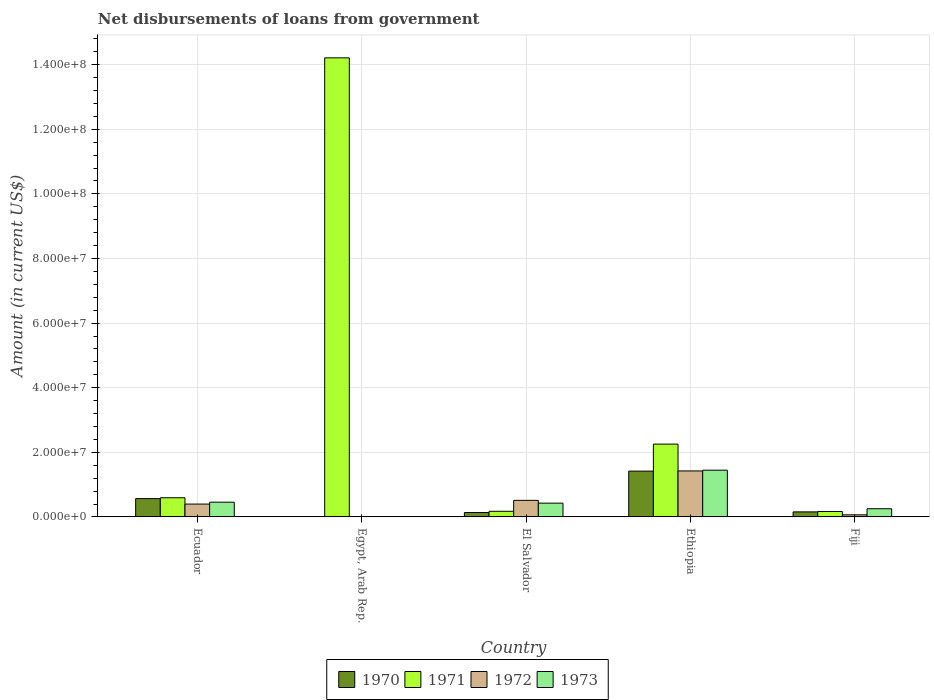How many different coloured bars are there?
Provide a short and direct response. 4. Are the number of bars per tick equal to the number of legend labels?
Offer a terse response. No. Are the number of bars on each tick of the X-axis equal?
Provide a succinct answer. No. What is the label of the 1st group of bars from the left?
Your answer should be compact. Ecuador. In how many cases, is the number of bars for a given country not equal to the number of legend labels?
Your response must be concise. 1. What is the amount of loan disbursed from government in 1972 in El Salvador?
Provide a short and direct response. 5.13e+06. Across all countries, what is the maximum amount of loan disbursed from government in 1973?
Keep it short and to the point. 1.45e+07. Across all countries, what is the minimum amount of loan disbursed from government in 1971?
Ensure brevity in your answer.  1.69e+06. In which country was the amount of loan disbursed from government in 1973 maximum?
Give a very brief answer. Ethiopia. What is the total amount of loan disbursed from government in 1970 in the graph?
Make the answer very short. 2.28e+07. What is the difference between the amount of loan disbursed from government in 1970 in Ecuador and that in El Salvador?
Ensure brevity in your answer.  4.32e+06. What is the difference between the amount of loan disbursed from government in 1973 in Ethiopia and the amount of loan disbursed from government in 1971 in Fiji?
Your answer should be compact. 1.28e+07. What is the average amount of loan disbursed from government in 1973 per country?
Your answer should be very brief. 5.17e+06. What is the difference between the amount of loan disbursed from government of/in 1972 and amount of loan disbursed from government of/in 1971 in El Salvador?
Provide a short and direct response. 3.39e+06. In how many countries, is the amount of loan disbursed from government in 1971 greater than 116000000 US$?
Give a very brief answer. 1. What is the ratio of the amount of loan disbursed from government in 1971 in Ecuador to that in Egypt, Arab Rep.?
Make the answer very short. 0.04. Is the amount of loan disbursed from government in 1973 in Ecuador less than that in Fiji?
Offer a terse response. No. What is the difference between the highest and the second highest amount of loan disbursed from government in 1973?
Give a very brief answer. 9.90e+06. What is the difference between the highest and the lowest amount of loan disbursed from government in 1971?
Make the answer very short. 1.40e+08. Is the sum of the amount of loan disbursed from government in 1971 in Ethiopia and Fiji greater than the maximum amount of loan disbursed from government in 1973 across all countries?
Your response must be concise. Yes. Is it the case that in every country, the sum of the amount of loan disbursed from government in 1973 and amount of loan disbursed from government in 1971 is greater than the sum of amount of loan disbursed from government in 1970 and amount of loan disbursed from government in 1972?
Provide a short and direct response. No. Is it the case that in every country, the sum of the amount of loan disbursed from government in 1970 and amount of loan disbursed from government in 1972 is greater than the amount of loan disbursed from government in 1971?
Provide a succinct answer. No. How many countries are there in the graph?
Offer a very short reply. 5. What is the difference between two consecutive major ticks on the Y-axis?
Your answer should be very brief. 2.00e+07. Are the values on the major ticks of Y-axis written in scientific E-notation?
Offer a very short reply. Yes. Does the graph contain any zero values?
Offer a terse response. Yes. Does the graph contain grids?
Offer a very short reply. Yes. Where does the legend appear in the graph?
Your answer should be very brief. Bottom center. What is the title of the graph?
Offer a very short reply. Net disbursements of loans from government. Does "1967" appear as one of the legend labels in the graph?
Your answer should be compact. No. What is the label or title of the X-axis?
Make the answer very short. Country. What is the Amount (in current US$) in 1970 in Ecuador?
Keep it short and to the point. 5.67e+06. What is the Amount (in current US$) in 1971 in Ecuador?
Offer a very short reply. 5.93e+06. What is the Amount (in current US$) in 1972 in Ecuador?
Give a very brief answer. 3.98e+06. What is the Amount (in current US$) of 1973 in Ecuador?
Provide a short and direct response. 4.56e+06. What is the Amount (in current US$) of 1970 in Egypt, Arab Rep.?
Your answer should be compact. 0. What is the Amount (in current US$) in 1971 in Egypt, Arab Rep.?
Keep it short and to the point. 1.42e+08. What is the Amount (in current US$) in 1973 in Egypt, Arab Rep.?
Ensure brevity in your answer.  0. What is the Amount (in current US$) in 1970 in El Salvador?
Provide a short and direct response. 1.36e+06. What is the Amount (in current US$) in 1971 in El Salvador?
Provide a succinct answer. 1.74e+06. What is the Amount (in current US$) of 1972 in El Salvador?
Provide a short and direct response. 5.13e+06. What is the Amount (in current US$) of 1973 in El Salvador?
Offer a very short reply. 4.27e+06. What is the Amount (in current US$) of 1970 in Ethiopia?
Ensure brevity in your answer.  1.42e+07. What is the Amount (in current US$) of 1971 in Ethiopia?
Provide a succinct answer. 2.25e+07. What is the Amount (in current US$) in 1972 in Ethiopia?
Keep it short and to the point. 1.42e+07. What is the Amount (in current US$) of 1973 in Ethiopia?
Your response must be concise. 1.45e+07. What is the Amount (in current US$) in 1970 in Fiji?
Make the answer very short. 1.56e+06. What is the Amount (in current US$) of 1971 in Fiji?
Give a very brief answer. 1.69e+06. What is the Amount (in current US$) in 1972 in Fiji?
Offer a terse response. 6.49e+05. What is the Amount (in current US$) of 1973 in Fiji?
Make the answer very short. 2.54e+06. Across all countries, what is the maximum Amount (in current US$) in 1970?
Make the answer very short. 1.42e+07. Across all countries, what is the maximum Amount (in current US$) in 1971?
Your answer should be very brief. 1.42e+08. Across all countries, what is the maximum Amount (in current US$) in 1972?
Provide a short and direct response. 1.42e+07. Across all countries, what is the maximum Amount (in current US$) in 1973?
Your answer should be compact. 1.45e+07. Across all countries, what is the minimum Amount (in current US$) of 1971?
Keep it short and to the point. 1.69e+06. Across all countries, what is the minimum Amount (in current US$) of 1973?
Keep it short and to the point. 0. What is the total Amount (in current US$) in 1970 in the graph?
Your answer should be very brief. 2.28e+07. What is the total Amount (in current US$) of 1971 in the graph?
Keep it short and to the point. 1.74e+08. What is the total Amount (in current US$) in 1972 in the graph?
Ensure brevity in your answer.  2.40e+07. What is the total Amount (in current US$) of 1973 in the graph?
Provide a succinct answer. 2.58e+07. What is the difference between the Amount (in current US$) in 1971 in Ecuador and that in Egypt, Arab Rep.?
Keep it short and to the point. -1.36e+08. What is the difference between the Amount (in current US$) in 1970 in Ecuador and that in El Salvador?
Offer a terse response. 4.32e+06. What is the difference between the Amount (in current US$) in 1971 in Ecuador and that in El Salvador?
Your answer should be compact. 4.19e+06. What is the difference between the Amount (in current US$) of 1972 in Ecuador and that in El Salvador?
Provide a succinct answer. -1.15e+06. What is the difference between the Amount (in current US$) of 1973 in Ecuador and that in El Salvador?
Ensure brevity in your answer.  2.91e+05. What is the difference between the Amount (in current US$) in 1970 in Ecuador and that in Ethiopia?
Keep it short and to the point. -8.50e+06. What is the difference between the Amount (in current US$) in 1971 in Ecuador and that in Ethiopia?
Offer a terse response. -1.66e+07. What is the difference between the Amount (in current US$) of 1972 in Ecuador and that in Ethiopia?
Provide a short and direct response. -1.03e+07. What is the difference between the Amount (in current US$) in 1973 in Ecuador and that in Ethiopia?
Ensure brevity in your answer.  -9.90e+06. What is the difference between the Amount (in current US$) of 1970 in Ecuador and that in Fiji?
Your response must be concise. 4.11e+06. What is the difference between the Amount (in current US$) of 1971 in Ecuador and that in Fiji?
Provide a short and direct response. 4.24e+06. What is the difference between the Amount (in current US$) in 1972 in Ecuador and that in Fiji?
Provide a short and direct response. 3.33e+06. What is the difference between the Amount (in current US$) of 1973 in Ecuador and that in Fiji?
Offer a very short reply. 2.02e+06. What is the difference between the Amount (in current US$) in 1971 in Egypt, Arab Rep. and that in El Salvador?
Your response must be concise. 1.40e+08. What is the difference between the Amount (in current US$) of 1971 in Egypt, Arab Rep. and that in Ethiopia?
Make the answer very short. 1.20e+08. What is the difference between the Amount (in current US$) of 1971 in Egypt, Arab Rep. and that in Fiji?
Your answer should be very brief. 1.40e+08. What is the difference between the Amount (in current US$) in 1970 in El Salvador and that in Ethiopia?
Keep it short and to the point. -1.28e+07. What is the difference between the Amount (in current US$) in 1971 in El Salvador and that in Ethiopia?
Give a very brief answer. -2.08e+07. What is the difference between the Amount (in current US$) of 1972 in El Salvador and that in Ethiopia?
Provide a short and direct response. -9.10e+06. What is the difference between the Amount (in current US$) of 1973 in El Salvador and that in Ethiopia?
Keep it short and to the point. -1.02e+07. What is the difference between the Amount (in current US$) in 1970 in El Salvador and that in Fiji?
Provide a succinct answer. -2.03e+05. What is the difference between the Amount (in current US$) of 1971 in El Salvador and that in Fiji?
Your response must be concise. 5.70e+04. What is the difference between the Amount (in current US$) of 1972 in El Salvador and that in Fiji?
Your answer should be compact. 4.48e+06. What is the difference between the Amount (in current US$) of 1973 in El Salvador and that in Fiji?
Your answer should be very brief. 1.73e+06. What is the difference between the Amount (in current US$) of 1970 in Ethiopia and that in Fiji?
Give a very brief answer. 1.26e+07. What is the difference between the Amount (in current US$) in 1971 in Ethiopia and that in Fiji?
Your answer should be very brief. 2.09e+07. What is the difference between the Amount (in current US$) of 1972 in Ethiopia and that in Fiji?
Offer a very short reply. 1.36e+07. What is the difference between the Amount (in current US$) in 1973 in Ethiopia and that in Fiji?
Provide a short and direct response. 1.19e+07. What is the difference between the Amount (in current US$) of 1970 in Ecuador and the Amount (in current US$) of 1971 in Egypt, Arab Rep.?
Keep it short and to the point. -1.36e+08. What is the difference between the Amount (in current US$) of 1970 in Ecuador and the Amount (in current US$) of 1971 in El Salvador?
Your answer should be very brief. 3.93e+06. What is the difference between the Amount (in current US$) in 1970 in Ecuador and the Amount (in current US$) in 1972 in El Salvador?
Your answer should be compact. 5.42e+05. What is the difference between the Amount (in current US$) in 1970 in Ecuador and the Amount (in current US$) in 1973 in El Salvador?
Provide a succinct answer. 1.40e+06. What is the difference between the Amount (in current US$) in 1971 in Ecuador and the Amount (in current US$) in 1972 in El Salvador?
Give a very brief answer. 8.02e+05. What is the difference between the Amount (in current US$) in 1971 in Ecuador and the Amount (in current US$) in 1973 in El Salvador?
Your answer should be very brief. 1.66e+06. What is the difference between the Amount (in current US$) in 1972 in Ecuador and the Amount (in current US$) in 1973 in El Salvador?
Offer a very short reply. -2.93e+05. What is the difference between the Amount (in current US$) of 1970 in Ecuador and the Amount (in current US$) of 1971 in Ethiopia?
Ensure brevity in your answer.  -1.69e+07. What is the difference between the Amount (in current US$) in 1970 in Ecuador and the Amount (in current US$) in 1972 in Ethiopia?
Ensure brevity in your answer.  -8.56e+06. What is the difference between the Amount (in current US$) of 1970 in Ecuador and the Amount (in current US$) of 1973 in Ethiopia?
Provide a succinct answer. -8.79e+06. What is the difference between the Amount (in current US$) of 1971 in Ecuador and the Amount (in current US$) of 1972 in Ethiopia?
Ensure brevity in your answer.  -8.30e+06. What is the difference between the Amount (in current US$) of 1971 in Ecuador and the Amount (in current US$) of 1973 in Ethiopia?
Provide a short and direct response. -8.53e+06. What is the difference between the Amount (in current US$) in 1972 in Ecuador and the Amount (in current US$) in 1973 in Ethiopia?
Ensure brevity in your answer.  -1.05e+07. What is the difference between the Amount (in current US$) in 1970 in Ecuador and the Amount (in current US$) in 1971 in Fiji?
Make the answer very short. 3.98e+06. What is the difference between the Amount (in current US$) of 1970 in Ecuador and the Amount (in current US$) of 1972 in Fiji?
Your answer should be compact. 5.02e+06. What is the difference between the Amount (in current US$) of 1970 in Ecuador and the Amount (in current US$) of 1973 in Fiji?
Your response must be concise. 3.13e+06. What is the difference between the Amount (in current US$) in 1971 in Ecuador and the Amount (in current US$) in 1972 in Fiji?
Offer a terse response. 5.28e+06. What is the difference between the Amount (in current US$) of 1971 in Ecuador and the Amount (in current US$) of 1973 in Fiji?
Provide a succinct answer. 3.39e+06. What is the difference between the Amount (in current US$) of 1972 in Ecuador and the Amount (in current US$) of 1973 in Fiji?
Your response must be concise. 1.44e+06. What is the difference between the Amount (in current US$) of 1971 in Egypt, Arab Rep. and the Amount (in current US$) of 1972 in El Salvador?
Your response must be concise. 1.37e+08. What is the difference between the Amount (in current US$) of 1971 in Egypt, Arab Rep. and the Amount (in current US$) of 1973 in El Salvador?
Offer a terse response. 1.38e+08. What is the difference between the Amount (in current US$) in 1971 in Egypt, Arab Rep. and the Amount (in current US$) in 1972 in Ethiopia?
Make the answer very short. 1.28e+08. What is the difference between the Amount (in current US$) of 1971 in Egypt, Arab Rep. and the Amount (in current US$) of 1973 in Ethiopia?
Keep it short and to the point. 1.28e+08. What is the difference between the Amount (in current US$) in 1971 in Egypt, Arab Rep. and the Amount (in current US$) in 1972 in Fiji?
Offer a terse response. 1.41e+08. What is the difference between the Amount (in current US$) in 1971 in Egypt, Arab Rep. and the Amount (in current US$) in 1973 in Fiji?
Offer a terse response. 1.40e+08. What is the difference between the Amount (in current US$) of 1970 in El Salvador and the Amount (in current US$) of 1971 in Ethiopia?
Give a very brief answer. -2.12e+07. What is the difference between the Amount (in current US$) in 1970 in El Salvador and the Amount (in current US$) in 1972 in Ethiopia?
Provide a short and direct response. -1.29e+07. What is the difference between the Amount (in current US$) in 1970 in El Salvador and the Amount (in current US$) in 1973 in Ethiopia?
Provide a short and direct response. -1.31e+07. What is the difference between the Amount (in current US$) of 1971 in El Salvador and the Amount (in current US$) of 1972 in Ethiopia?
Your answer should be compact. -1.25e+07. What is the difference between the Amount (in current US$) in 1971 in El Salvador and the Amount (in current US$) in 1973 in Ethiopia?
Keep it short and to the point. -1.27e+07. What is the difference between the Amount (in current US$) in 1972 in El Salvador and the Amount (in current US$) in 1973 in Ethiopia?
Give a very brief answer. -9.33e+06. What is the difference between the Amount (in current US$) of 1970 in El Salvador and the Amount (in current US$) of 1971 in Fiji?
Provide a short and direct response. -3.31e+05. What is the difference between the Amount (in current US$) of 1970 in El Salvador and the Amount (in current US$) of 1972 in Fiji?
Provide a succinct answer. 7.08e+05. What is the difference between the Amount (in current US$) in 1970 in El Salvador and the Amount (in current US$) in 1973 in Fiji?
Offer a terse response. -1.18e+06. What is the difference between the Amount (in current US$) in 1971 in El Salvador and the Amount (in current US$) in 1972 in Fiji?
Your response must be concise. 1.10e+06. What is the difference between the Amount (in current US$) in 1971 in El Salvador and the Amount (in current US$) in 1973 in Fiji?
Offer a very short reply. -7.94e+05. What is the difference between the Amount (in current US$) of 1972 in El Salvador and the Amount (in current US$) of 1973 in Fiji?
Make the answer very short. 2.59e+06. What is the difference between the Amount (in current US$) of 1970 in Ethiopia and the Amount (in current US$) of 1971 in Fiji?
Provide a short and direct response. 1.25e+07. What is the difference between the Amount (in current US$) of 1970 in Ethiopia and the Amount (in current US$) of 1972 in Fiji?
Your response must be concise. 1.35e+07. What is the difference between the Amount (in current US$) in 1970 in Ethiopia and the Amount (in current US$) in 1973 in Fiji?
Give a very brief answer. 1.16e+07. What is the difference between the Amount (in current US$) in 1971 in Ethiopia and the Amount (in current US$) in 1972 in Fiji?
Your response must be concise. 2.19e+07. What is the difference between the Amount (in current US$) in 1971 in Ethiopia and the Amount (in current US$) in 1973 in Fiji?
Give a very brief answer. 2.00e+07. What is the difference between the Amount (in current US$) of 1972 in Ethiopia and the Amount (in current US$) of 1973 in Fiji?
Give a very brief answer. 1.17e+07. What is the average Amount (in current US$) in 1970 per country?
Give a very brief answer. 4.55e+06. What is the average Amount (in current US$) of 1971 per country?
Provide a short and direct response. 3.48e+07. What is the average Amount (in current US$) of 1972 per country?
Provide a succinct answer. 4.80e+06. What is the average Amount (in current US$) of 1973 per country?
Offer a terse response. 5.17e+06. What is the difference between the Amount (in current US$) in 1970 and Amount (in current US$) in 1972 in Ecuador?
Keep it short and to the point. 1.69e+06. What is the difference between the Amount (in current US$) of 1970 and Amount (in current US$) of 1973 in Ecuador?
Offer a very short reply. 1.11e+06. What is the difference between the Amount (in current US$) in 1971 and Amount (in current US$) in 1972 in Ecuador?
Provide a short and direct response. 1.95e+06. What is the difference between the Amount (in current US$) of 1971 and Amount (in current US$) of 1973 in Ecuador?
Give a very brief answer. 1.37e+06. What is the difference between the Amount (in current US$) in 1972 and Amount (in current US$) in 1973 in Ecuador?
Make the answer very short. -5.84e+05. What is the difference between the Amount (in current US$) in 1970 and Amount (in current US$) in 1971 in El Salvador?
Keep it short and to the point. -3.88e+05. What is the difference between the Amount (in current US$) in 1970 and Amount (in current US$) in 1972 in El Salvador?
Provide a short and direct response. -3.77e+06. What is the difference between the Amount (in current US$) of 1970 and Amount (in current US$) of 1973 in El Salvador?
Your answer should be very brief. -2.92e+06. What is the difference between the Amount (in current US$) in 1971 and Amount (in current US$) in 1972 in El Salvador?
Your answer should be compact. -3.39e+06. What is the difference between the Amount (in current US$) of 1971 and Amount (in current US$) of 1973 in El Salvador?
Make the answer very short. -2.53e+06. What is the difference between the Amount (in current US$) of 1972 and Amount (in current US$) of 1973 in El Salvador?
Offer a terse response. 8.59e+05. What is the difference between the Amount (in current US$) in 1970 and Amount (in current US$) in 1971 in Ethiopia?
Offer a terse response. -8.36e+06. What is the difference between the Amount (in current US$) of 1970 and Amount (in current US$) of 1972 in Ethiopia?
Your response must be concise. -5.80e+04. What is the difference between the Amount (in current US$) in 1970 and Amount (in current US$) in 1973 in Ethiopia?
Your answer should be compact. -2.85e+05. What is the difference between the Amount (in current US$) in 1971 and Amount (in current US$) in 1972 in Ethiopia?
Give a very brief answer. 8.31e+06. What is the difference between the Amount (in current US$) of 1971 and Amount (in current US$) of 1973 in Ethiopia?
Offer a terse response. 8.08e+06. What is the difference between the Amount (in current US$) in 1972 and Amount (in current US$) in 1973 in Ethiopia?
Provide a succinct answer. -2.27e+05. What is the difference between the Amount (in current US$) of 1970 and Amount (in current US$) of 1971 in Fiji?
Offer a terse response. -1.28e+05. What is the difference between the Amount (in current US$) of 1970 and Amount (in current US$) of 1972 in Fiji?
Your answer should be very brief. 9.11e+05. What is the difference between the Amount (in current US$) in 1970 and Amount (in current US$) in 1973 in Fiji?
Your response must be concise. -9.79e+05. What is the difference between the Amount (in current US$) of 1971 and Amount (in current US$) of 1972 in Fiji?
Your answer should be very brief. 1.04e+06. What is the difference between the Amount (in current US$) in 1971 and Amount (in current US$) in 1973 in Fiji?
Ensure brevity in your answer.  -8.51e+05. What is the difference between the Amount (in current US$) in 1972 and Amount (in current US$) in 1973 in Fiji?
Make the answer very short. -1.89e+06. What is the ratio of the Amount (in current US$) of 1971 in Ecuador to that in Egypt, Arab Rep.?
Offer a terse response. 0.04. What is the ratio of the Amount (in current US$) in 1970 in Ecuador to that in El Salvador?
Give a very brief answer. 4.18. What is the ratio of the Amount (in current US$) of 1971 in Ecuador to that in El Salvador?
Offer a terse response. 3.4. What is the ratio of the Amount (in current US$) in 1972 in Ecuador to that in El Salvador?
Your answer should be very brief. 0.78. What is the ratio of the Amount (in current US$) of 1973 in Ecuador to that in El Salvador?
Offer a terse response. 1.07. What is the ratio of the Amount (in current US$) of 1970 in Ecuador to that in Ethiopia?
Provide a succinct answer. 0.4. What is the ratio of the Amount (in current US$) of 1971 in Ecuador to that in Ethiopia?
Ensure brevity in your answer.  0.26. What is the ratio of the Amount (in current US$) in 1972 in Ecuador to that in Ethiopia?
Offer a terse response. 0.28. What is the ratio of the Amount (in current US$) of 1973 in Ecuador to that in Ethiopia?
Ensure brevity in your answer.  0.32. What is the ratio of the Amount (in current US$) of 1970 in Ecuador to that in Fiji?
Provide a short and direct response. 3.64. What is the ratio of the Amount (in current US$) of 1971 in Ecuador to that in Fiji?
Keep it short and to the point. 3.51. What is the ratio of the Amount (in current US$) in 1972 in Ecuador to that in Fiji?
Offer a terse response. 6.13. What is the ratio of the Amount (in current US$) of 1973 in Ecuador to that in Fiji?
Provide a short and direct response. 1.8. What is the ratio of the Amount (in current US$) of 1971 in Egypt, Arab Rep. to that in El Salvador?
Your response must be concise. 81.43. What is the ratio of the Amount (in current US$) of 1971 in Egypt, Arab Rep. to that in Ethiopia?
Provide a succinct answer. 6.3. What is the ratio of the Amount (in current US$) of 1971 in Egypt, Arab Rep. to that in Fiji?
Your answer should be very brief. 84.18. What is the ratio of the Amount (in current US$) of 1970 in El Salvador to that in Ethiopia?
Keep it short and to the point. 0.1. What is the ratio of the Amount (in current US$) in 1971 in El Salvador to that in Ethiopia?
Provide a short and direct response. 0.08. What is the ratio of the Amount (in current US$) of 1972 in El Salvador to that in Ethiopia?
Your answer should be compact. 0.36. What is the ratio of the Amount (in current US$) in 1973 in El Salvador to that in Ethiopia?
Your answer should be compact. 0.3. What is the ratio of the Amount (in current US$) of 1970 in El Salvador to that in Fiji?
Offer a very short reply. 0.87. What is the ratio of the Amount (in current US$) of 1971 in El Salvador to that in Fiji?
Provide a short and direct response. 1.03. What is the ratio of the Amount (in current US$) of 1972 in El Salvador to that in Fiji?
Make the answer very short. 7.91. What is the ratio of the Amount (in current US$) in 1973 in El Salvador to that in Fiji?
Offer a terse response. 1.68. What is the ratio of the Amount (in current US$) of 1970 in Ethiopia to that in Fiji?
Your response must be concise. 9.09. What is the ratio of the Amount (in current US$) in 1971 in Ethiopia to that in Fiji?
Offer a terse response. 13.35. What is the ratio of the Amount (in current US$) in 1972 in Ethiopia to that in Fiji?
Provide a short and direct response. 21.94. What is the ratio of the Amount (in current US$) in 1973 in Ethiopia to that in Fiji?
Your response must be concise. 5.7. What is the difference between the highest and the second highest Amount (in current US$) in 1970?
Your response must be concise. 8.50e+06. What is the difference between the highest and the second highest Amount (in current US$) of 1971?
Offer a terse response. 1.20e+08. What is the difference between the highest and the second highest Amount (in current US$) of 1972?
Your answer should be compact. 9.10e+06. What is the difference between the highest and the second highest Amount (in current US$) in 1973?
Make the answer very short. 9.90e+06. What is the difference between the highest and the lowest Amount (in current US$) of 1970?
Make the answer very short. 1.42e+07. What is the difference between the highest and the lowest Amount (in current US$) in 1971?
Provide a short and direct response. 1.40e+08. What is the difference between the highest and the lowest Amount (in current US$) in 1972?
Offer a very short reply. 1.42e+07. What is the difference between the highest and the lowest Amount (in current US$) of 1973?
Offer a terse response. 1.45e+07. 